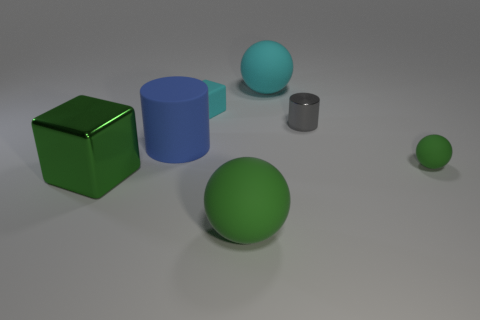Add 1 tiny green rubber spheres. How many objects exist? 8 Subtract all spheres. How many objects are left? 4 Add 7 large cyan things. How many large cyan things are left? 8 Add 3 green shiny objects. How many green shiny objects exist? 4 Subtract 0 brown cubes. How many objects are left? 7 Subtract all rubber balls. Subtract all tiny cyan objects. How many objects are left? 3 